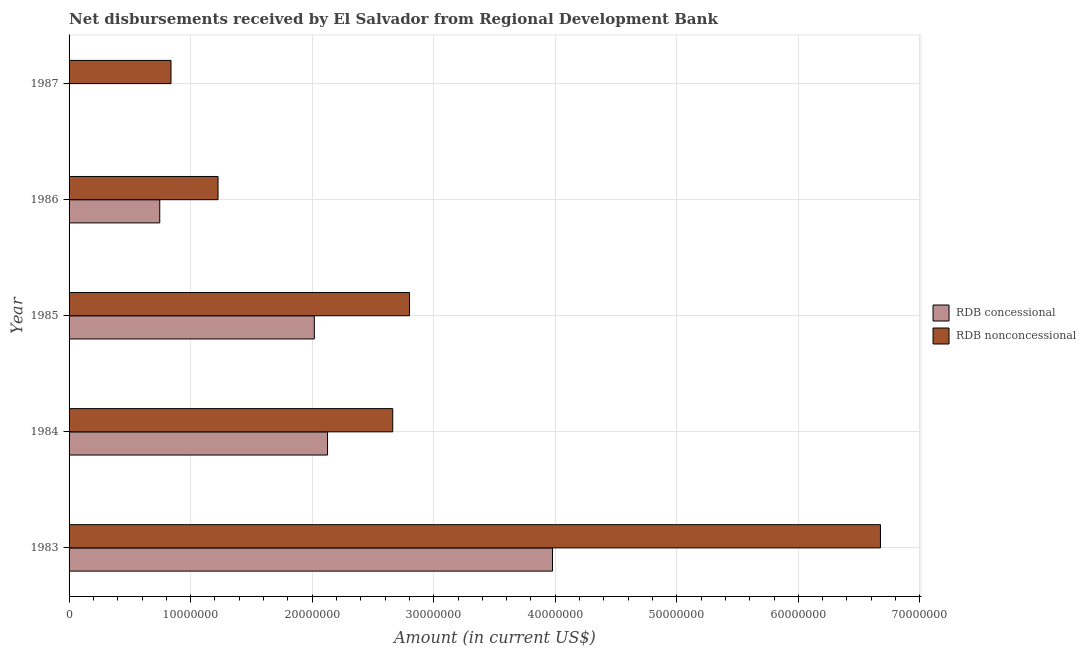Are the number of bars per tick equal to the number of legend labels?
Your response must be concise. No. How many bars are there on the 3rd tick from the bottom?
Offer a terse response. 2. What is the label of the 2nd group of bars from the top?
Keep it short and to the point. 1986. In how many cases, is the number of bars for a given year not equal to the number of legend labels?
Provide a short and direct response. 1. Across all years, what is the maximum net non concessional disbursements from rdb?
Give a very brief answer. 6.68e+07. Across all years, what is the minimum net non concessional disbursements from rdb?
Provide a succinct answer. 8.39e+06. What is the total net concessional disbursements from rdb in the graph?
Give a very brief answer. 8.87e+07. What is the difference between the net concessional disbursements from rdb in 1984 and that in 1986?
Make the answer very short. 1.38e+07. What is the difference between the net concessional disbursements from rdb in 1987 and the net non concessional disbursements from rdb in 1985?
Your answer should be very brief. -2.80e+07. What is the average net non concessional disbursements from rdb per year?
Your response must be concise. 2.84e+07. In the year 1986, what is the difference between the net concessional disbursements from rdb and net non concessional disbursements from rdb?
Provide a succinct answer. -4.79e+06. In how many years, is the net concessional disbursements from rdb greater than 44000000 US$?
Provide a short and direct response. 0. What is the ratio of the net concessional disbursements from rdb in 1984 to that in 1986?
Provide a short and direct response. 2.85. What is the difference between the highest and the second highest net non concessional disbursements from rdb?
Provide a short and direct response. 3.87e+07. What is the difference between the highest and the lowest net non concessional disbursements from rdb?
Your answer should be compact. 5.84e+07. How many bars are there?
Your answer should be very brief. 9. Are the values on the major ticks of X-axis written in scientific E-notation?
Your answer should be very brief. No. Does the graph contain any zero values?
Provide a short and direct response. Yes. What is the title of the graph?
Ensure brevity in your answer.  Net disbursements received by El Salvador from Regional Development Bank. What is the label or title of the Y-axis?
Give a very brief answer. Year. What is the Amount (in current US$) in RDB concessional in 1983?
Give a very brief answer. 3.98e+07. What is the Amount (in current US$) of RDB nonconcessional in 1983?
Ensure brevity in your answer.  6.68e+07. What is the Amount (in current US$) of RDB concessional in 1984?
Keep it short and to the point. 2.13e+07. What is the Amount (in current US$) in RDB nonconcessional in 1984?
Ensure brevity in your answer.  2.66e+07. What is the Amount (in current US$) in RDB concessional in 1985?
Offer a terse response. 2.02e+07. What is the Amount (in current US$) in RDB nonconcessional in 1985?
Your answer should be compact. 2.80e+07. What is the Amount (in current US$) in RDB concessional in 1986?
Make the answer very short. 7.46e+06. What is the Amount (in current US$) of RDB nonconcessional in 1986?
Your answer should be compact. 1.23e+07. What is the Amount (in current US$) of RDB nonconcessional in 1987?
Your answer should be compact. 8.39e+06. Across all years, what is the maximum Amount (in current US$) of RDB concessional?
Your answer should be compact. 3.98e+07. Across all years, what is the maximum Amount (in current US$) of RDB nonconcessional?
Provide a succinct answer. 6.68e+07. Across all years, what is the minimum Amount (in current US$) of RDB concessional?
Offer a very short reply. 0. Across all years, what is the minimum Amount (in current US$) of RDB nonconcessional?
Give a very brief answer. 8.39e+06. What is the total Amount (in current US$) in RDB concessional in the graph?
Provide a short and direct response. 8.87e+07. What is the total Amount (in current US$) in RDB nonconcessional in the graph?
Ensure brevity in your answer.  1.42e+08. What is the difference between the Amount (in current US$) in RDB concessional in 1983 and that in 1984?
Ensure brevity in your answer.  1.85e+07. What is the difference between the Amount (in current US$) of RDB nonconcessional in 1983 and that in 1984?
Your response must be concise. 4.01e+07. What is the difference between the Amount (in current US$) of RDB concessional in 1983 and that in 1985?
Make the answer very short. 1.96e+07. What is the difference between the Amount (in current US$) of RDB nonconcessional in 1983 and that in 1985?
Your answer should be compact. 3.87e+07. What is the difference between the Amount (in current US$) of RDB concessional in 1983 and that in 1986?
Ensure brevity in your answer.  3.23e+07. What is the difference between the Amount (in current US$) in RDB nonconcessional in 1983 and that in 1986?
Provide a short and direct response. 5.45e+07. What is the difference between the Amount (in current US$) in RDB nonconcessional in 1983 and that in 1987?
Provide a short and direct response. 5.84e+07. What is the difference between the Amount (in current US$) of RDB concessional in 1984 and that in 1985?
Your answer should be compact. 1.09e+06. What is the difference between the Amount (in current US$) in RDB nonconcessional in 1984 and that in 1985?
Your response must be concise. -1.38e+06. What is the difference between the Amount (in current US$) of RDB concessional in 1984 and that in 1986?
Keep it short and to the point. 1.38e+07. What is the difference between the Amount (in current US$) of RDB nonconcessional in 1984 and that in 1986?
Your answer should be very brief. 1.44e+07. What is the difference between the Amount (in current US$) of RDB nonconcessional in 1984 and that in 1987?
Provide a succinct answer. 1.82e+07. What is the difference between the Amount (in current US$) of RDB concessional in 1985 and that in 1986?
Make the answer very short. 1.27e+07. What is the difference between the Amount (in current US$) of RDB nonconcessional in 1985 and that in 1986?
Offer a terse response. 1.58e+07. What is the difference between the Amount (in current US$) of RDB nonconcessional in 1985 and that in 1987?
Offer a very short reply. 1.96e+07. What is the difference between the Amount (in current US$) in RDB nonconcessional in 1986 and that in 1987?
Your response must be concise. 3.87e+06. What is the difference between the Amount (in current US$) of RDB concessional in 1983 and the Amount (in current US$) of RDB nonconcessional in 1984?
Provide a short and direct response. 1.31e+07. What is the difference between the Amount (in current US$) in RDB concessional in 1983 and the Amount (in current US$) in RDB nonconcessional in 1985?
Your response must be concise. 1.18e+07. What is the difference between the Amount (in current US$) in RDB concessional in 1983 and the Amount (in current US$) in RDB nonconcessional in 1986?
Your answer should be very brief. 2.75e+07. What is the difference between the Amount (in current US$) in RDB concessional in 1983 and the Amount (in current US$) in RDB nonconcessional in 1987?
Ensure brevity in your answer.  3.14e+07. What is the difference between the Amount (in current US$) in RDB concessional in 1984 and the Amount (in current US$) in RDB nonconcessional in 1985?
Your answer should be very brief. -6.74e+06. What is the difference between the Amount (in current US$) of RDB concessional in 1984 and the Amount (in current US$) of RDB nonconcessional in 1986?
Your response must be concise. 9.01e+06. What is the difference between the Amount (in current US$) in RDB concessional in 1984 and the Amount (in current US$) in RDB nonconcessional in 1987?
Ensure brevity in your answer.  1.29e+07. What is the difference between the Amount (in current US$) of RDB concessional in 1985 and the Amount (in current US$) of RDB nonconcessional in 1986?
Provide a succinct answer. 7.92e+06. What is the difference between the Amount (in current US$) of RDB concessional in 1985 and the Amount (in current US$) of RDB nonconcessional in 1987?
Make the answer very short. 1.18e+07. What is the difference between the Amount (in current US$) in RDB concessional in 1986 and the Amount (in current US$) in RDB nonconcessional in 1987?
Offer a very short reply. -9.25e+05. What is the average Amount (in current US$) of RDB concessional per year?
Offer a very short reply. 1.77e+07. What is the average Amount (in current US$) in RDB nonconcessional per year?
Make the answer very short. 2.84e+07. In the year 1983, what is the difference between the Amount (in current US$) in RDB concessional and Amount (in current US$) in RDB nonconcessional?
Make the answer very short. -2.70e+07. In the year 1984, what is the difference between the Amount (in current US$) of RDB concessional and Amount (in current US$) of RDB nonconcessional?
Ensure brevity in your answer.  -5.36e+06. In the year 1985, what is the difference between the Amount (in current US$) in RDB concessional and Amount (in current US$) in RDB nonconcessional?
Provide a succinct answer. -7.83e+06. In the year 1986, what is the difference between the Amount (in current US$) of RDB concessional and Amount (in current US$) of RDB nonconcessional?
Give a very brief answer. -4.79e+06. What is the ratio of the Amount (in current US$) of RDB concessional in 1983 to that in 1984?
Offer a very short reply. 1.87. What is the ratio of the Amount (in current US$) in RDB nonconcessional in 1983 to that in 1984?
Ensure brevity in your answer.  2.51. What is the ratio of the Amount (in current US$) in RDB concessional in 1983 to that in 1985?
Give a very brief answer. 1.97. What is the ratio of the Amount (in current US$) of RDB nonconcessional in 1983 to that in 1985?
Give a very brief answer. 2.38. What is the ratio of the Amount (in current US$) in RDB concessional in 1983 to that in 1986?
Your response must be concise. 5.33. What is the ratio of the Amount (in current US$) of RDB nonconcessional in 1983 to that in 1986?
Offer a very short reply. 5.45. What is the ratio of the Amount (in current US$) of RDB nonconcessional in 1983 to that in 1987?
Make the answer very short. 7.96. What is the ratio of the Amount (in current US$) of RDB concessional in 1984 to that in 1985?
Provide a succinct answer. 1.05. What is the ratio of the Amount (in current US$) in RDB nonconcessional in 1984 to that in 1985?
Offer a very short reply. 0.95. What is the ratio of the Amount (in current US$) of RDB concessional in 1984 to that in 1986?
Your answer should be very brief. 2.85. What is the ratio of the Amount (in current US$) in RDB nonconcessional in 1984 to that in 1986?
Keep it short and to the point. 2.17. What is the ratio of the Amount (in current US$) in RDB nonconcessional in 1984 to that in 1987?
Offer a terse response. 3.18. What is the ratio of the Amount (in current US$) in RDB concessional in 1985 to that in 1986?
Your response must be concise. 2.7. What is the ratio of the Amount (in current US$) of RDB nonconcessional in 1985 to that in 1986?
Your response must be concise. 2.29. What is the ratio of the Amount (in current US$) in RDB nonconcessional in 1985 to that in 1987?
Ensure brevity in your answer.  3.34. What is the ratio of the Amount (in current US$) of RDB nonconcessional in 1986 to that in 1987?
Your answer should be very brief. 1.46. What is the difference between the highest and the second highest Amount (in current US$) of RDB concessional?
Make the answer very short. 1.85e+07. What is the difference between the highest and the second highest Amount (in current US$) in RDB nonconcessional?
Your answer should be compact. 3.87e+07. What is the difference between the highest and the lowest Amount (in current US$) of RDB concessional?
Your answer should be very brief. 3.98e+07. What is the difference between the highest and the lowest Amount (in current US$) in RDB nonconcessional?
Offer a terse response. 5.84e+07. 